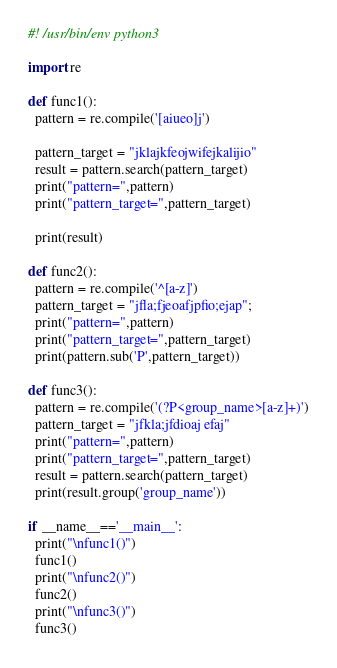<code> <loc_0><loc_0><loc_500><loc_500><_Python_>#! /usr/bin/env python3

import re

def func1():
  pattern = re.compile('[aiueo]j')

  pattern_target = "jklajkfeojwifejkalijio"
  result = pattern.search(pattern_target)
  print("pattern=",pattern)
  print("pattern_target=",pattern_target)

  print(result)

def func2():
  pattern = re.compile('^[a-z]')
  pattern_target = "jfla;fjeoafjpfio;ejap";
  print("pattern=",pattern)
  print("pattern_target=",pattern_target)
  print(pattern.sub('P',pattern_target))

def func3():
  pattern = re.compile('(?P<group_name>[a-z]+)')
  pattern_target = "jfkla;jfdioaj efaj"
  print("pattern=",pattern)
  print("pattern_target=",pattern_target)
  result = pattern.search(pattern_target)
  print(result.group('group_name'))

if __name__=='__main__':
  print("\nfunc1()")
  func1()
  print("\nfunc2()")
  func2()
  print("\nfunc3()")
  func3()

</code> 